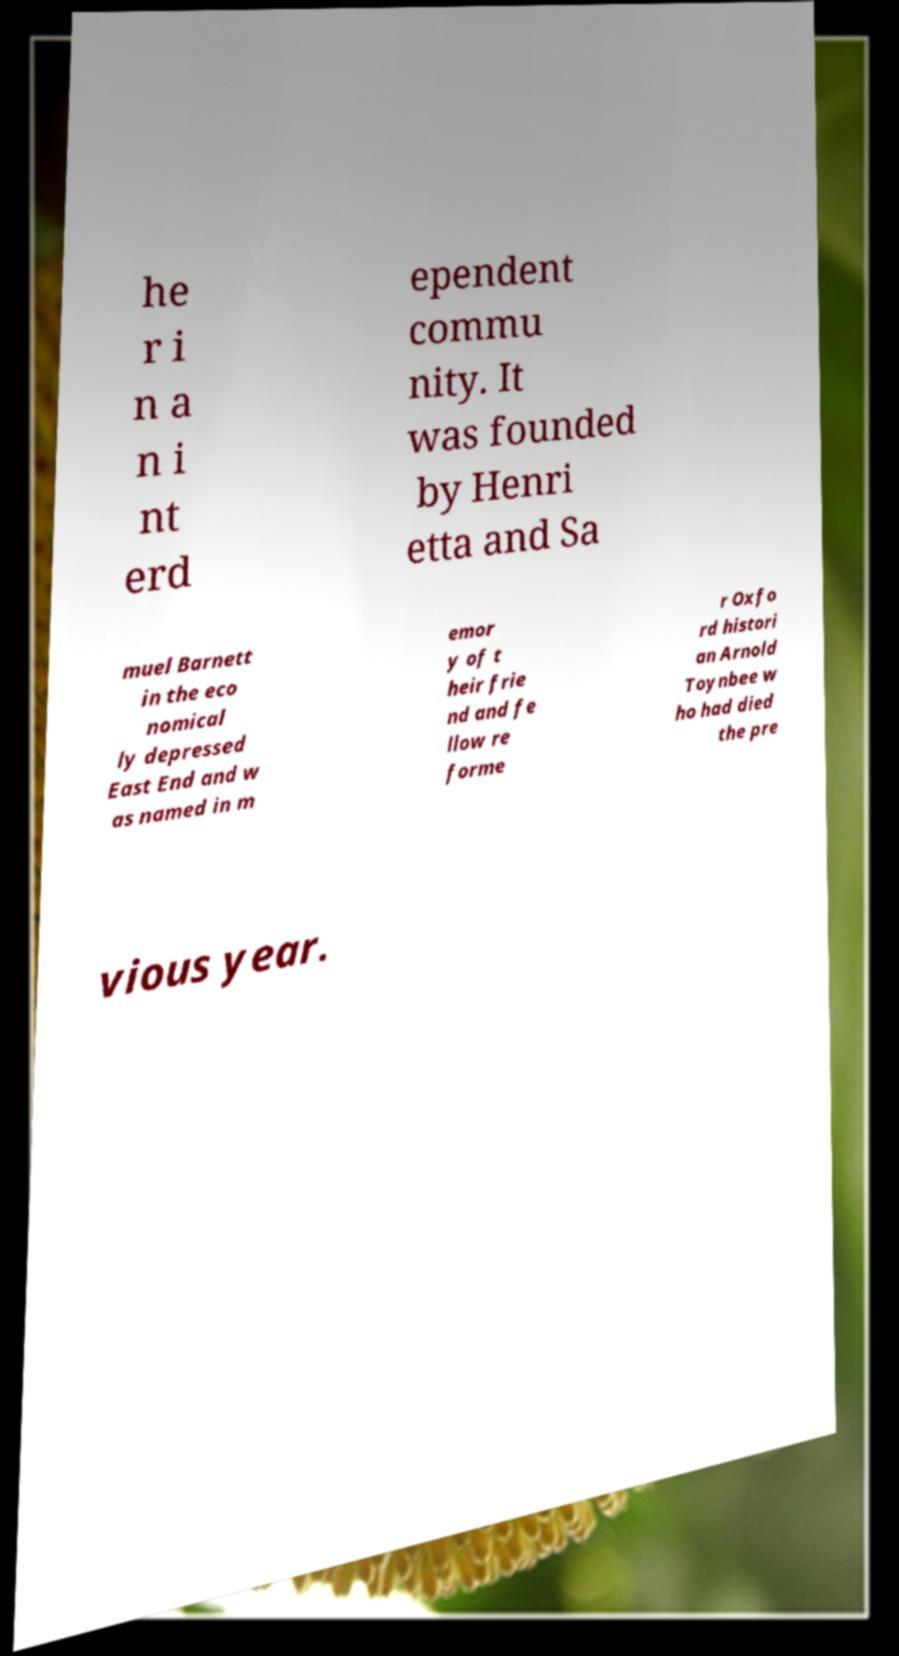For documentation purposes, I need the text within this image transcribed. Could you provide that? he r i n a n i nt erd ependent commu nity. It was founded by Henri etta and Sa muel Barnett in the eco nomical ly depressed East End and w as named in m emor y of t heir frie nd and fe llow re forme r Oxfo rd histori an Arnold Toynbee w ho had died the pre vious year. 